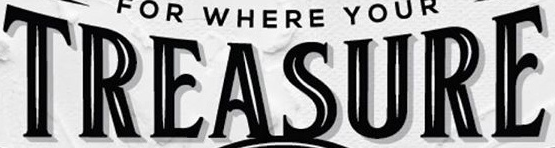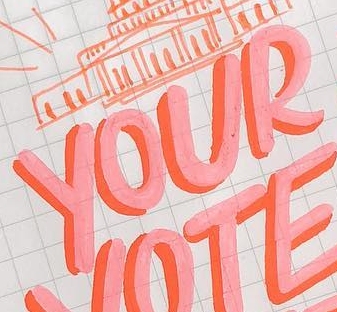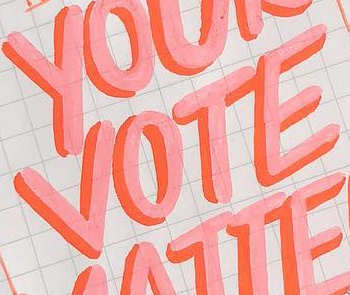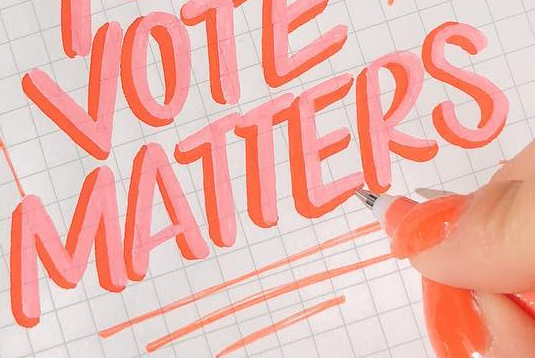Read the text from these images in sequence, separated by a semicolon. TREASURE; YOUR; VOTE; MATTERS 